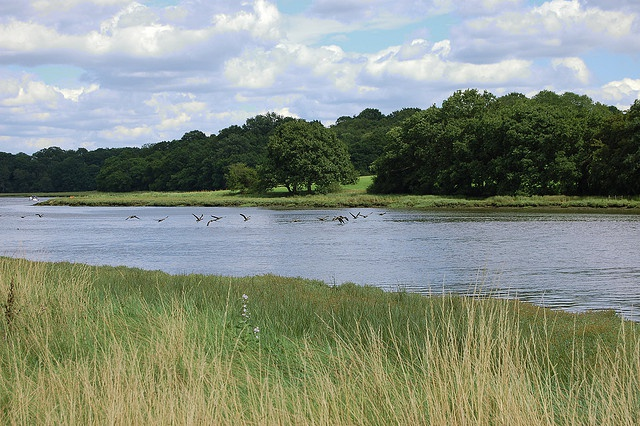Describe the objects in this image and their specific colors. I can see bird in lavender, black, darkgray, and gray tones, bird in lavender, darkgray, and gray tones, bird in lavender, black, gray, and darkgray tones, bird in lavender, black, darkgray, gray, and lightgray tones, and bird in lavender, darkgray, gray, and black tones in this image. 